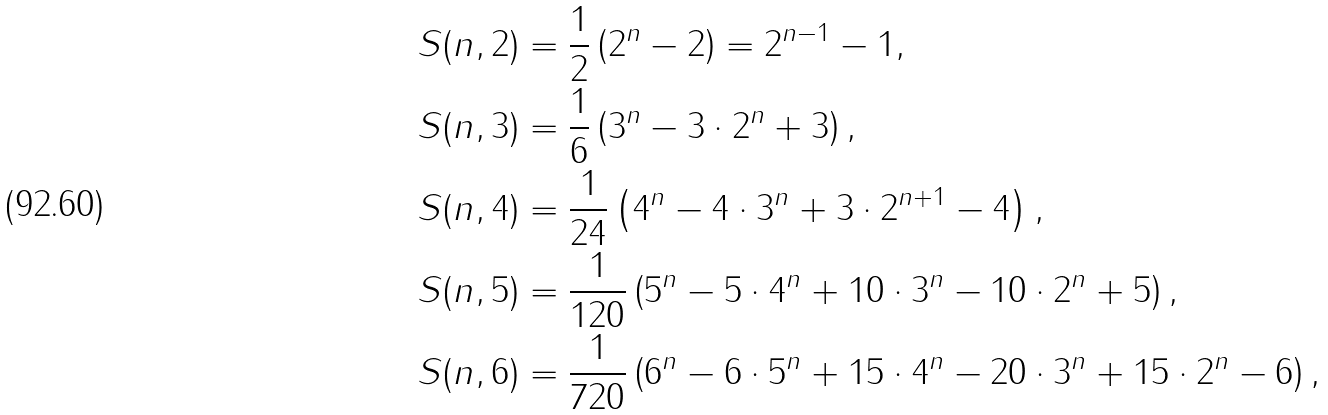<formula> <loc_0><loc_0><loc_500><loc_500>& S ( n , 2 ) = \frac { 1 } { 2 } \left ( 2 ^ { n } - 2 \right ) = 2 ^ { n - 1 } - 1 , \\ & S ( n , 3 ) = \frac { 1 } { 6 } \left ( 3 ^ { n } - 3 \cdot 2 ^ { n } + 3 \right ) , \\ & S ( n , 4 ) = \frac { 1 } { 2 4 } \left ( 4 ^ { n } - 4 \cdot 3 ^ { n } + 3 \cdot 2 ^ { n + 1 } - 4 \right ) , \\ & S ( n , 5 ) = \frac { 1 } { 1 2 0 } \left ( 5 ^ { n } - 5 \cdot 4 ^ { n } + 1 0 \cdot 3 ^ { n } - 1 0 \cdot 2 ^ { n } + 5 \right ) , \\ & S ( n , 6 ) = \frac { 1 } { 7 2 0 } \left ( 6 ^ { n } - 6 \cdot 5 ^ { n } + 1 5 \cdot 4 ^ { n } - 2 0 \cdot 3 ^ { n } + 1 5 \cdot 2 ^ { n } - 6 \right ) ,</formula> 